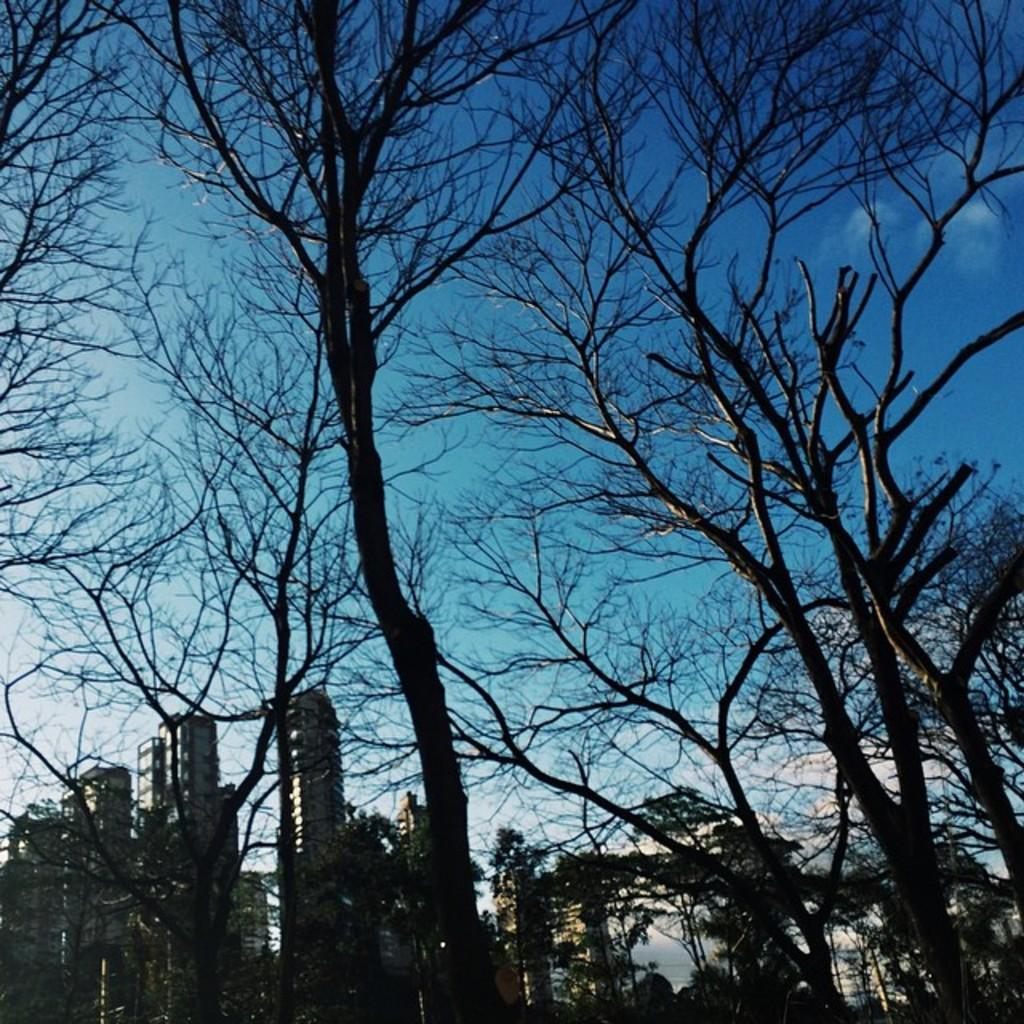What is the overall lighting condition of the image? The image is dark. What type of natural elements can be seen in the image? There are trees in the image. What type of man-made structures are present in the image? There are buildings in the image. What can be seen in the distance in the image? The sky is visible in the background of the image. How many baskets are hanging from the trees in the image? There are no baskets present in the image; it only features trees and buildings. 